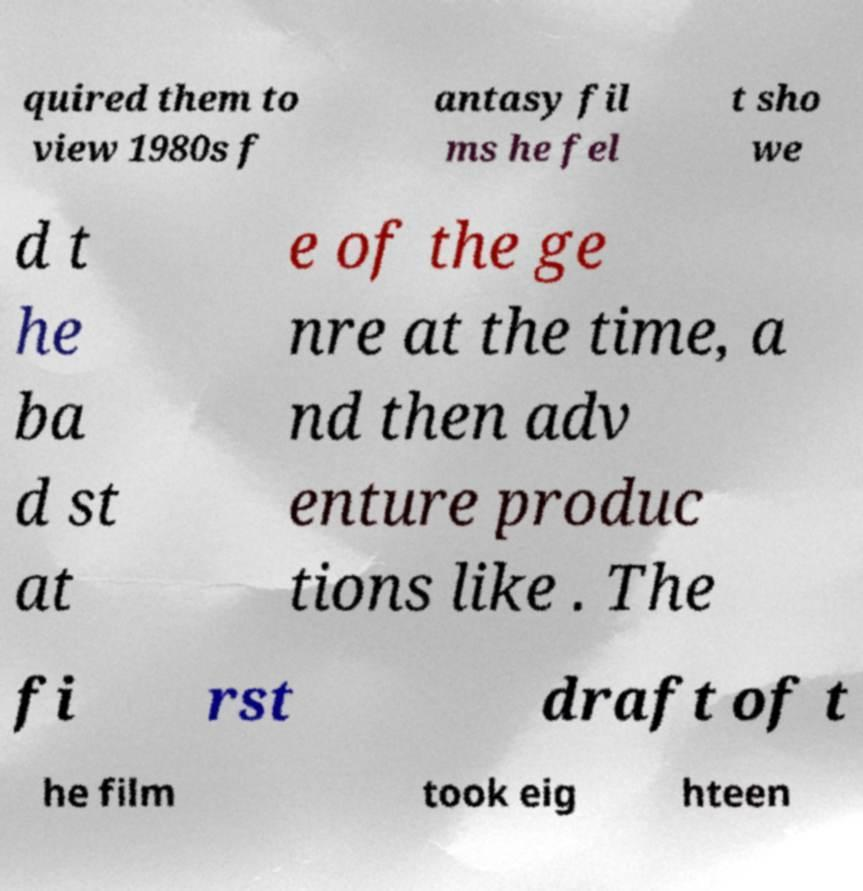Please identify and transcribe the text found in this image. quired them to view 1980s f antasy fil ms he fel t sho we d t he ba d st at e of the ge nre at the time, a nd then adv enture produc tions like . The fi rst draft of t he film took eig hteen 